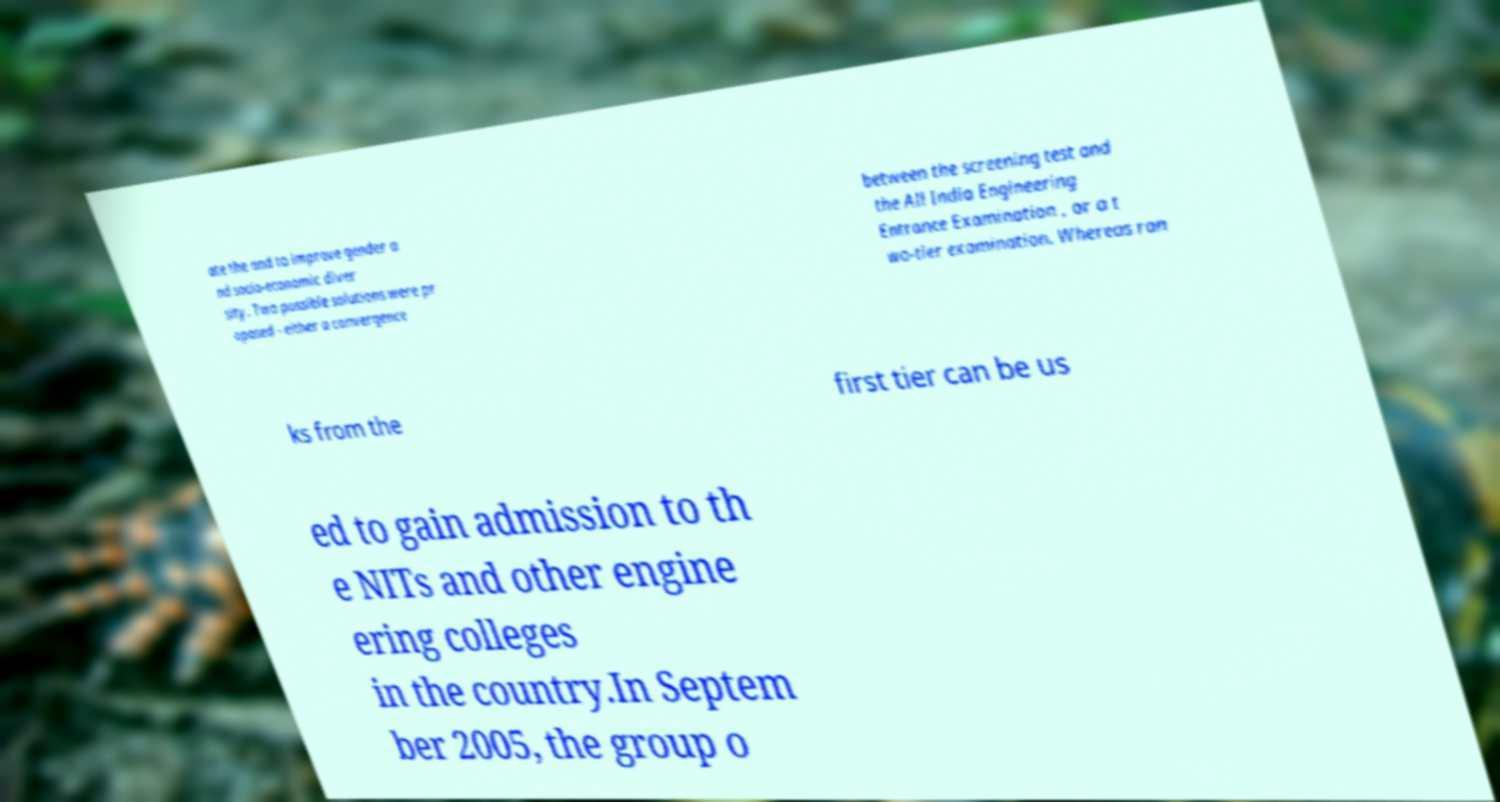Please identify and transcribe the text found in this image. ate the and to improve gender a nd socio-economic diver sity. Two possible solutions were pr oposed - either a convergence between the screening test and the All India Engineering Entrance Examination , or a t wo-tier examination. Whereas ran ks from the first tier can be us ed to gain admission to th e NITs and other engine ering colleges in the country.In Septem ber 2005, the group o 